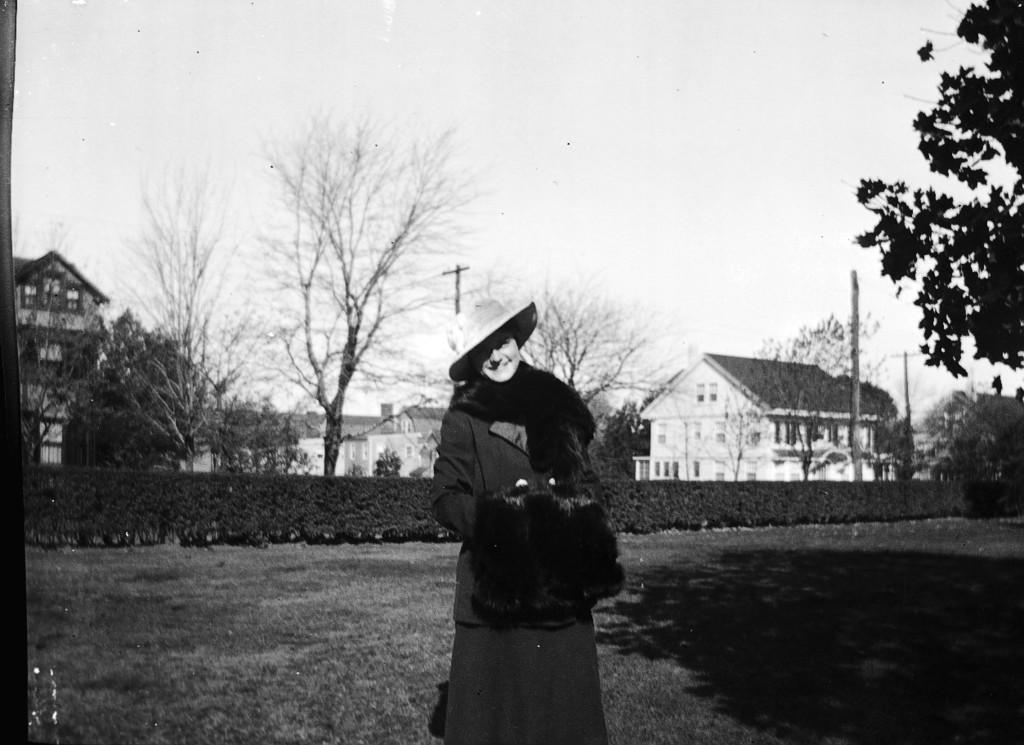Please provide a concise description of this image. In this image we can see a black and white photo. In this image we can see a person, plants, grass, trees, houses and other objects. On the right side top of the image it looks like a tree. At the top of the image there is the sky. 